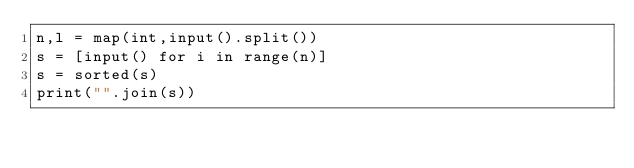Convert code to text. <code><loc_0><loc_0><loc_500><loc_500><_Python_>n,l = map(int,input().split())
s = [input() for i in range(n)]
s = sorted(s)
print("".join(s))</code> 